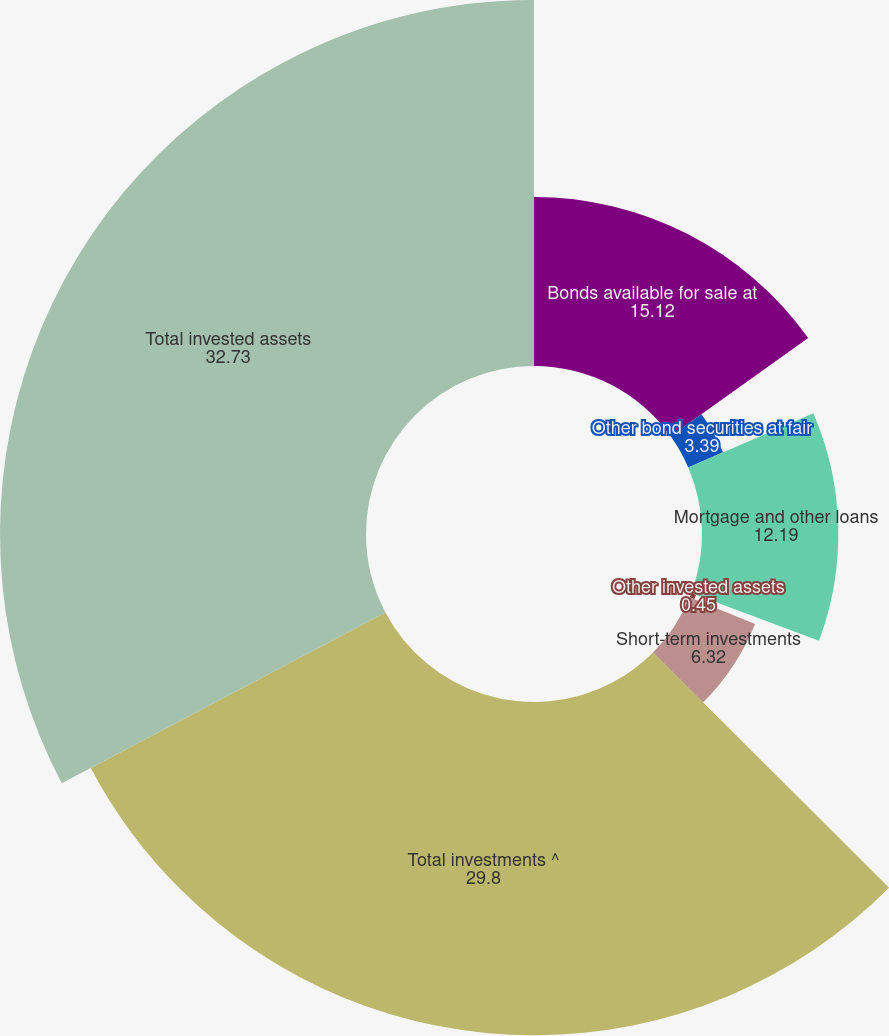Convert chart to OTSL. <chart><loc_0><loc_0><loc_500><loc_500><pie_chart><fcel>Bonds available for sale at<fcel>Other bond securities at fair<fcel>Mortgage and other loans<fcel>Other invested assets<fcel>Short-term investments<fcel>Total investments ^<fcel>Total invested assets<nl><fcel>15.12%<fcel>3.39%<fcel>12.19%<fcel>0.45%<fcel>6.32%<fcel>29.8%<fcel>32.73%<nl></chart> 